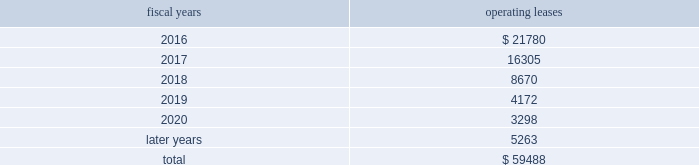Analog devices , inc .
Notes to consolidated financial statements 2014 ( continued ) the following is a schedule of future minimum rental payments required under long-term operating leases at october 31 , operating fiscal years leases .
12 .
Commitments and contingencies from time to time , in the ordinary course of the company 2019s business , various claims , charges and litigation are asserted or commenced against the company arising from , or related to , contractual matters , patents , trademarks , personal injury , environmental matters , product liability , insurance coverage and personnel and employment disputes .
As to such claims and litigation , the company can give no assurance that it will prevail .
The company does not believe that any current legal matters will have a material adverse effect on the company 2019s financial position , results of operations or cash flows .
13 .
Retirement plans the company and its subsidiaries have various savings and retirement plans covering substantially all employees .
The company maintains a defined contribution plan for the benefit of its eligible u.s .
Employees .
This plan provides for company contributions of up to 5% ( 5 % ) of each participant 2019s total eligible compensation .
In addition , the company contributes an amount equal to each participant 2019s pre-tax contribution , if any , up to a maximum of 3% ( 3 % ) of each participant 2019s total eligible compensation .
The total expense related to the defined contribution plan for u.s .
Employees was $ 26.3 million in fiscal 2015 , $ 24.1 million in fiscal 2014 and $ 23.1 million in fiscal 2013 .
The company also has various defined benefit pension and other retirement plans for certain non-u.s .
Employees that are consistent with local statutory requirements and practices .
The total expense related to the various defined benefit pension and other retirement plans for certain non-u.s .
Employees , excluding settlement charges related to the company's irish defined benefit plan , was $ 33.3 million in fiscal 2015 , $ 29.8 million in fiscal 2014 and $ 26.5 million in fiscal 2013 .
Non-u.s .
Plan disclosures during fiscal 2015 , the company converted the benefits provided to participants in the company 2019s irish defined benefits pension plan ( the db plan ) to benefits provided under the company 2019s irish defined contribution plan .
As a result , in fiscal 2015 the company recorded expenses of $ 223.7 million , including settlement charges , legal , accounting and other professional fees to settle the pension obligation .
The assets related to the db plan were liquidated and used to purchase annuities for retirees and distributed to active and deferred members' accounts in the company's irish defined contribution plan in connection with the plan conversion .
Accordingly , plan assets for the db plan were zero as of the end of fiscal 2015 .
The company 2019s funding policy for its foreign defined benefit pension plans is consistent with the local requirements of each country .
The plans 2019 assets consist primarily of u.s .
And non-u.s .
Equity securities , bonds , property and cash .
The benefit obligations and related assets under these plans have been measured at october 31 , 2015 and november 1 , 2014 .
Components of net periodic benefit cost net annual periodic pension cost of non-u.s .
Plans is presented in the following table: .
What percent of the leases was paid off in 2016? 
Rationale: to find the percentage that was paid off in the first year one must divide the payment the first year by the total amount . this gives you the percentage that was paid off that year .
Computations: (21780 / 59488)
Answer: 0.36612. 